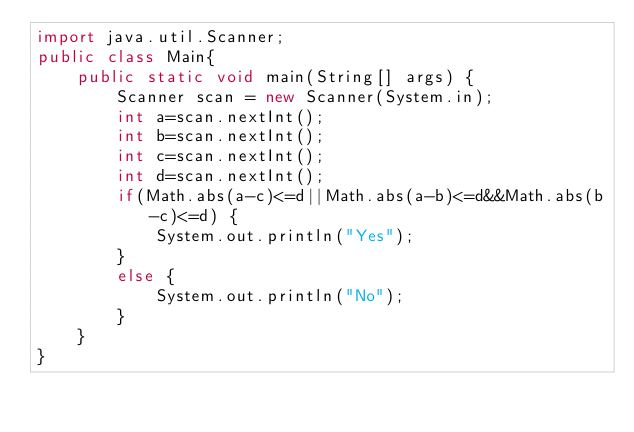Convert code to text. <code><loc_0><loc_0><loc_500><loc_500><_Java_>import java.util.Scanner;
public class Main{
	public static void main(String[] args) {
		Scanner scan = new Scanner(System.in);
		int a=scan.nextInt();
		int b=scan.nextInt();
		int c=scan.nextInt();
		int d=scan.nextInt();
		if(Math.abs(a-c)<=d||Math.abs(a-b)<=d&&Math.abs(b-c)<=d) {
			System.out.println("Yes");
		}
		else {
			System.out.println("No");
		}
	}
}</code> 